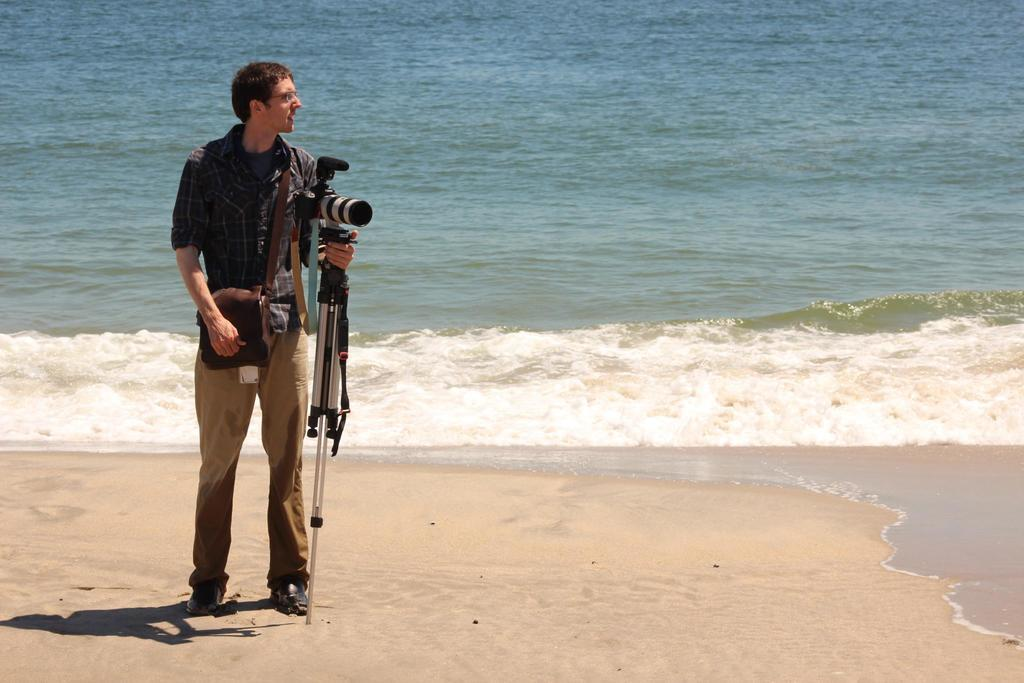What object belonging to a person can be seen in the image? There is a person's bag in the image. What is the person holding in the image? The person is holding a camera stand. What type of terrain is visible at the bottom of the image? There is sand visible at the bottom of the image. What can be seen in the distance in the image? There is a water surface in the background of the image. What type of copper material is present in the image? There is no copper material present in the image. How much butter is visible in the image? There is no butter present in the image. 